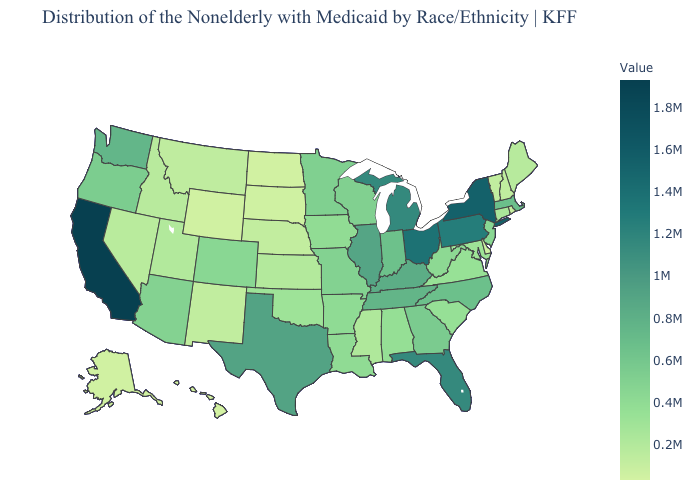Among the states that border Texas , which have the highest value?
Write a very short answer. Arkansas. Does Washington have the lowest value in the USA?
Be succinct. No. Does Nevada have the highest value in the West?
Answer briefly. No. Does Kentucky have a higher value than Ohio?
Write a very short answer. No. Does California have the highest value in the USA?
Concise answer only. Yes. 